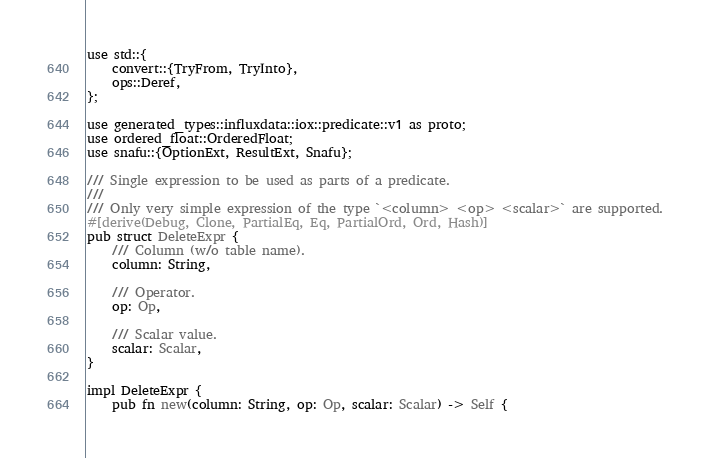<code> <loc_0><loc_0><loc_500><loc_500><_Rust_>use std::{
    convert::{TryFrom, TryInto},
    ops::Deref,
};

use generated_types::influxdata::iox::predicate::v1 as proto;
use ordered_float::OrderedFloat;
use snafu::{OptionExt, ResultExt, Snafu};

/// Single expression to be used as parts of a predicate.
///
/// Only very simple expression of the type `<column> <op> <scalar>` are supported.
#[derive(Debug, Clone, PartialEq, Eq, PartialOrd, Ord, Hash)]
pub struct DeleteExpr {
    /// Column (w/o table name).
    column: String,

    /// Operator.
    op: Op,

    /// Scalar value.
    scalar: Scalar,
}

impl DeleteExpr {
    pub fn new(column: String, op: Op, scalar: Scalar) -> Self {</code> 